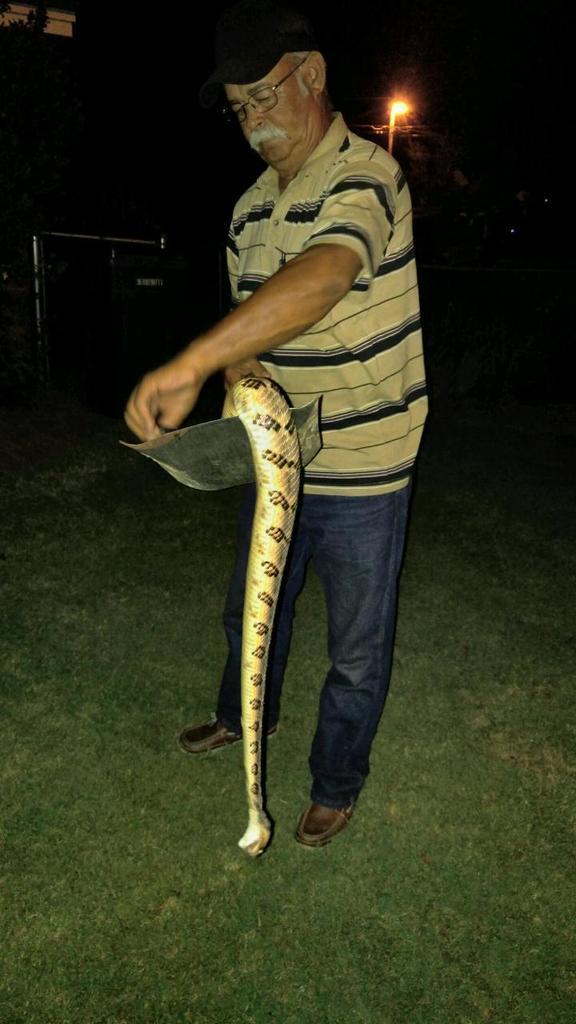In one or two sentences, can you explain what this image depicts? A man wearing specs and cap is holding a snake in a plate. On the ground it is grass. In the background there is a light. 